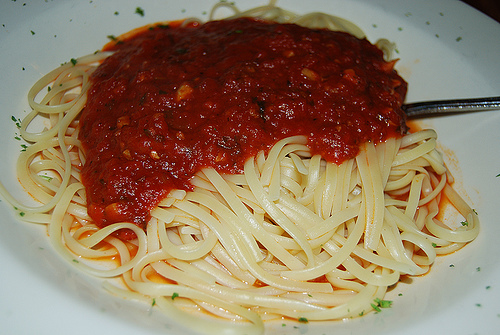<image>
Is the noodle in the fork? Yes. The noodle is contained within or inside the fork, showing a containment relationship. Is the sauce next to the noodles? No. The sauce is not positioned next to the noodles. They are located in different areas of the scene. 